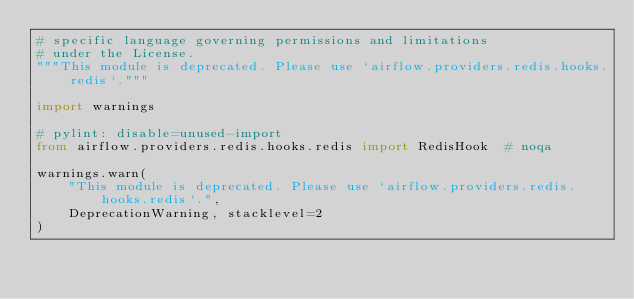<code> <loc_0><loc_0><loc_500><loc_500><_Python_># specific language governing permissions and limitations
# under the License.
"""This module is deprecated. Please use `airflow.providers.redis.hooks.redis`."""

import warnings

# pylint: disable=unused-import
from airflow.providers.redis.hooks.redis import RedisHook  # noqa

warnings.warn(
    "This module is deprecated. Please use `airflow.providers.redis.hooks.redis`.",
    DeprecationWarning, stacklevel=2
)
</code> 